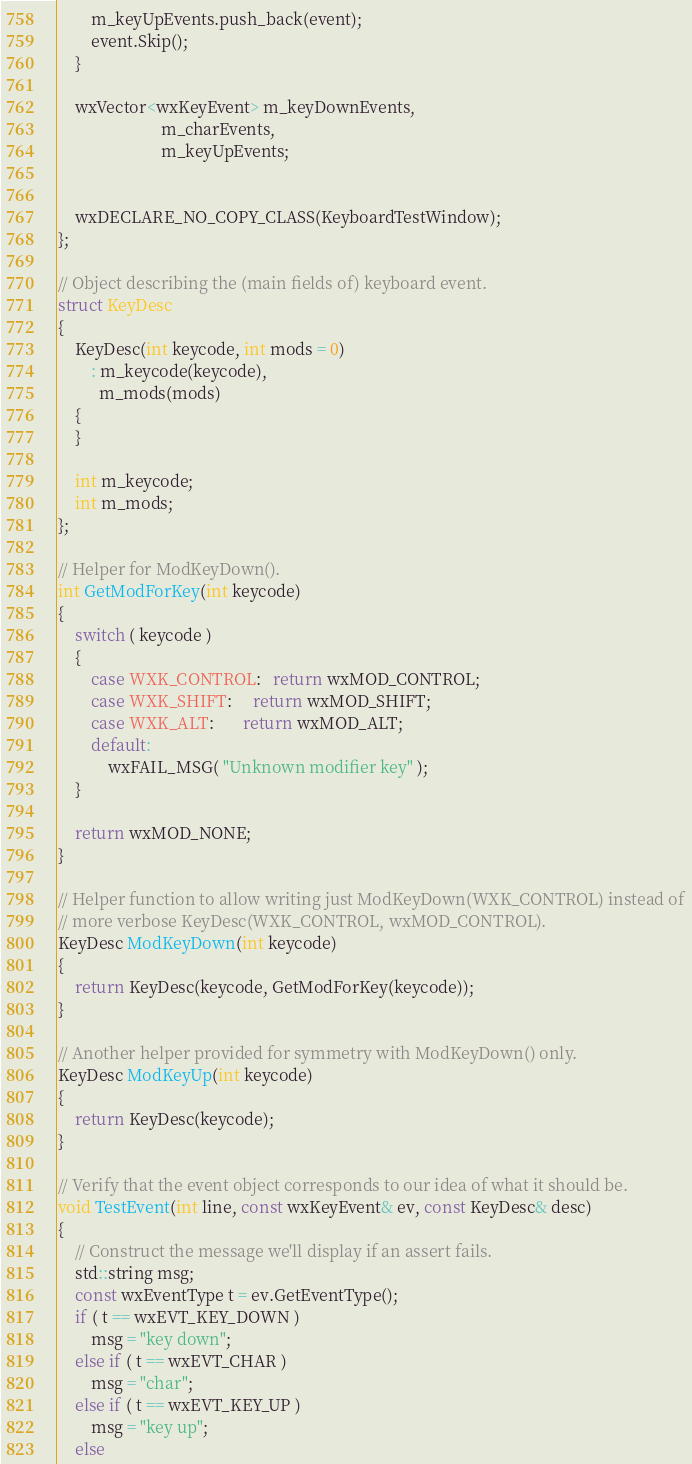Convert code to text. <code><loc_0><loc_0><loc_500><loc_500><_C++_>        m_keyUpEvents.push_back(event);
        event.Skip();
    }

    wxVector<wxKeyEvent> m_keyDownEvents,
                         m_charEvents,
                         m_keyUpEvents;


    wxDECLARE_NO_COPY_CLASS(KeyboardTestWindow);
};

// Object describing the (main fields of) keyboard event.
struct KeyDesc
{
    KeyDesc(int keycode, int mods = 0)
        : m_keycode(keycode),
          m_mods(mods)
    {
    }

    int m_keycode;
    int m_mods;
};

// Helper for ModKeyDown().
int GetModForKey(int keycode)
{
    switch ( keycode )
    {
        case WXK_CONTROL:   return wxMOD_CONTROL;
        case WXK_SHIFT:     return wxMOD_SHIFT;
        case WXK_ALT:       return wxMOD_ALT;
        default:
            wxFAIL_MSG( "Unknown modifier key" );
    }

    return wxMOD_NONE;
}

// Helper function to allow writing just ModKeyDown(WXK_CONTROL) instead of
// more verbose KeyDesc(WXK_CONTROL, wxMOD_CONTROL).
KeyDesc ModKeyDown(int keycode)
{
    return KeyDesc(keycode, GetModForKey(keycode));
}

// Another helper provided for symmetry with ModKeyDown() only.
KeyDesc ModKeyUp(int keycode)
{
    return KeyDesc(keycode);
}

// Verify that the event object corresponds to our idea of what it should be.
void TestEvent(int line, const wxKeyEvent& ev, const KeyDesc& desc)
{
    // Construct the message we'll display if an assert fails.
    std::string msg;
    const wxEventType t = ev.GetEventType();
    if ( t == wxEVT_KEY_DOWN )
        msg = "key down";
    else if ( t == wxEVT_CHAR )
        msg = "char";
    else if ( t == wxEVT_KEY_UP )
        msg = "key up";
    else</code> 